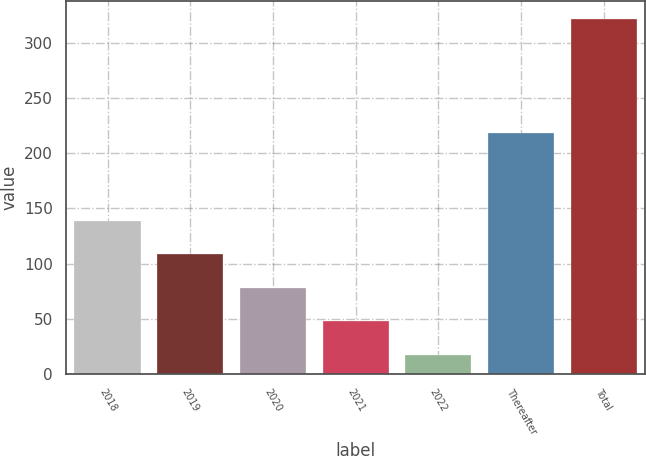Convert chart to OTSL. <chart><loc_0><loc_0><loc_500><loc_500><bar_chart><fcel>2018<fcel>2019<fcel>2020<fcel>2021<fcel>2022<fcel>Thereafter<fcel>Total<nl><fcel>139<fcel>108.6<fcel>78.2<fcel>47.8<fcel>17.4<fcel>218.4<fcel>321.4<nl></chart> 